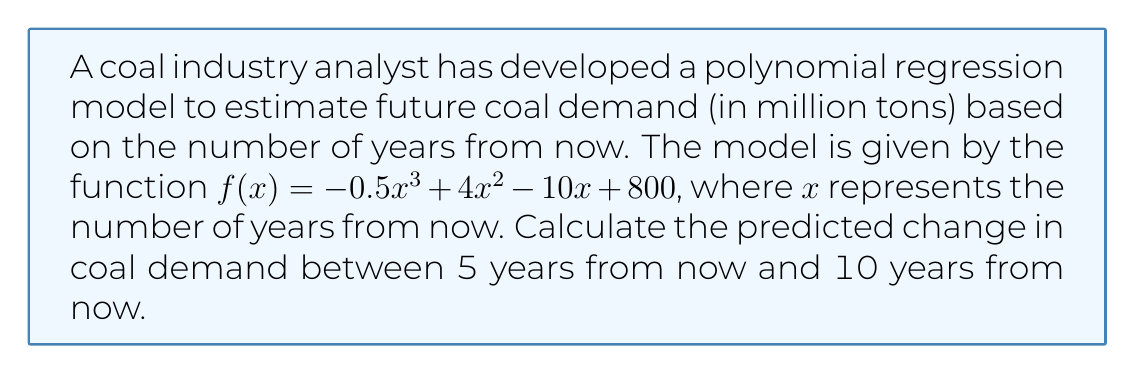Teach me how to tackle this problem. To solve this problem, we need to follow these steps:

1. Calculate the coal demand 5 years from now:
   $f(5) = -0.5(5)^3 + 4(5)^2 - 10(5) + 800$
   $= -0.5(125) + 4(25) - 50 + 800$
   $= -62.5 + 100 - 50 + 800$
   $= 787.5$ million tons

2. Calculate the coal demand 10 years from now:
   $f(10) = -0.5(10)^3 + 4(10)^2 - 10(10) + 800$
   $= -0.5(1000) + 4(100) - 100 + 800$
   $= -500 + 400 - 100 + 800$
   $= 600$ million tons

3. Calculate the change in demand by subtracting the demand at 5 years from the demand at 10 years:
   Change in demand $= f(10) - f(5)$
   $= 600 - 787.5$
   $= -187.5$ million tons

The negative value indicates a decrease in demand over this period.
Answer: $-187.5$ million tons 